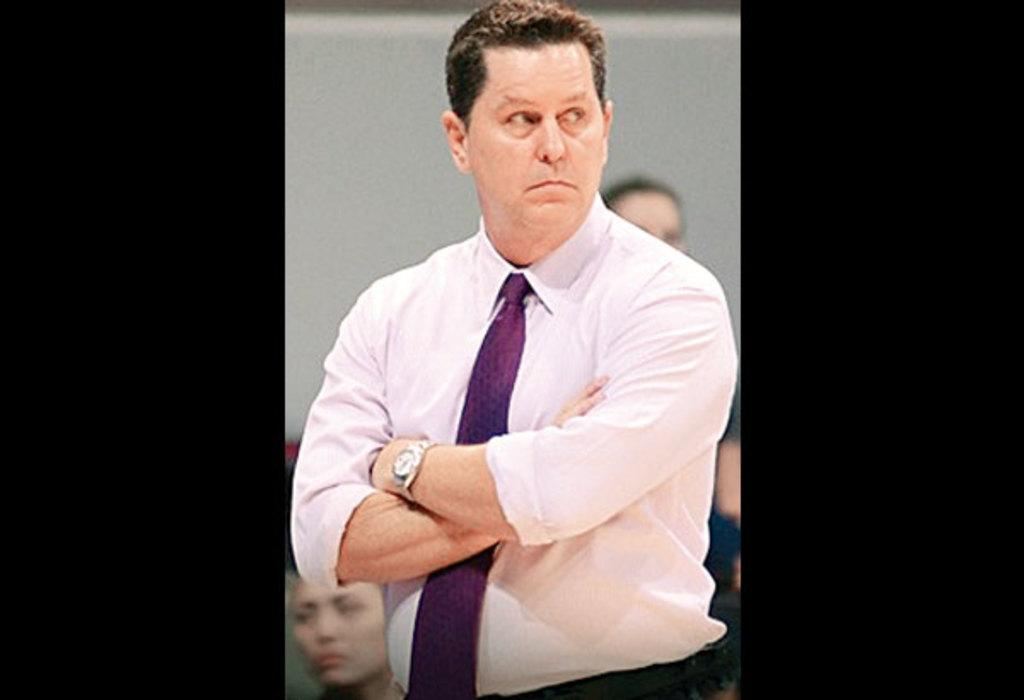Who is the main subject in the image? There is a man in the image. What is the man wearing on his upper body? The man is wearing a white shirt. What accessory is the man wearing around his neck? The man is wearing a purple tie. What can be seen in the background of the image? There are many people in the background of the image. What type of cemetery can be seen in the image? There is no cemetery present in the image; it features a man wearing a white shirt and purple tie. How many twists are there in the man's tie in the image? The provided facts do not mention the number of twists in the man's tie, so it cannot be determined from the image. 